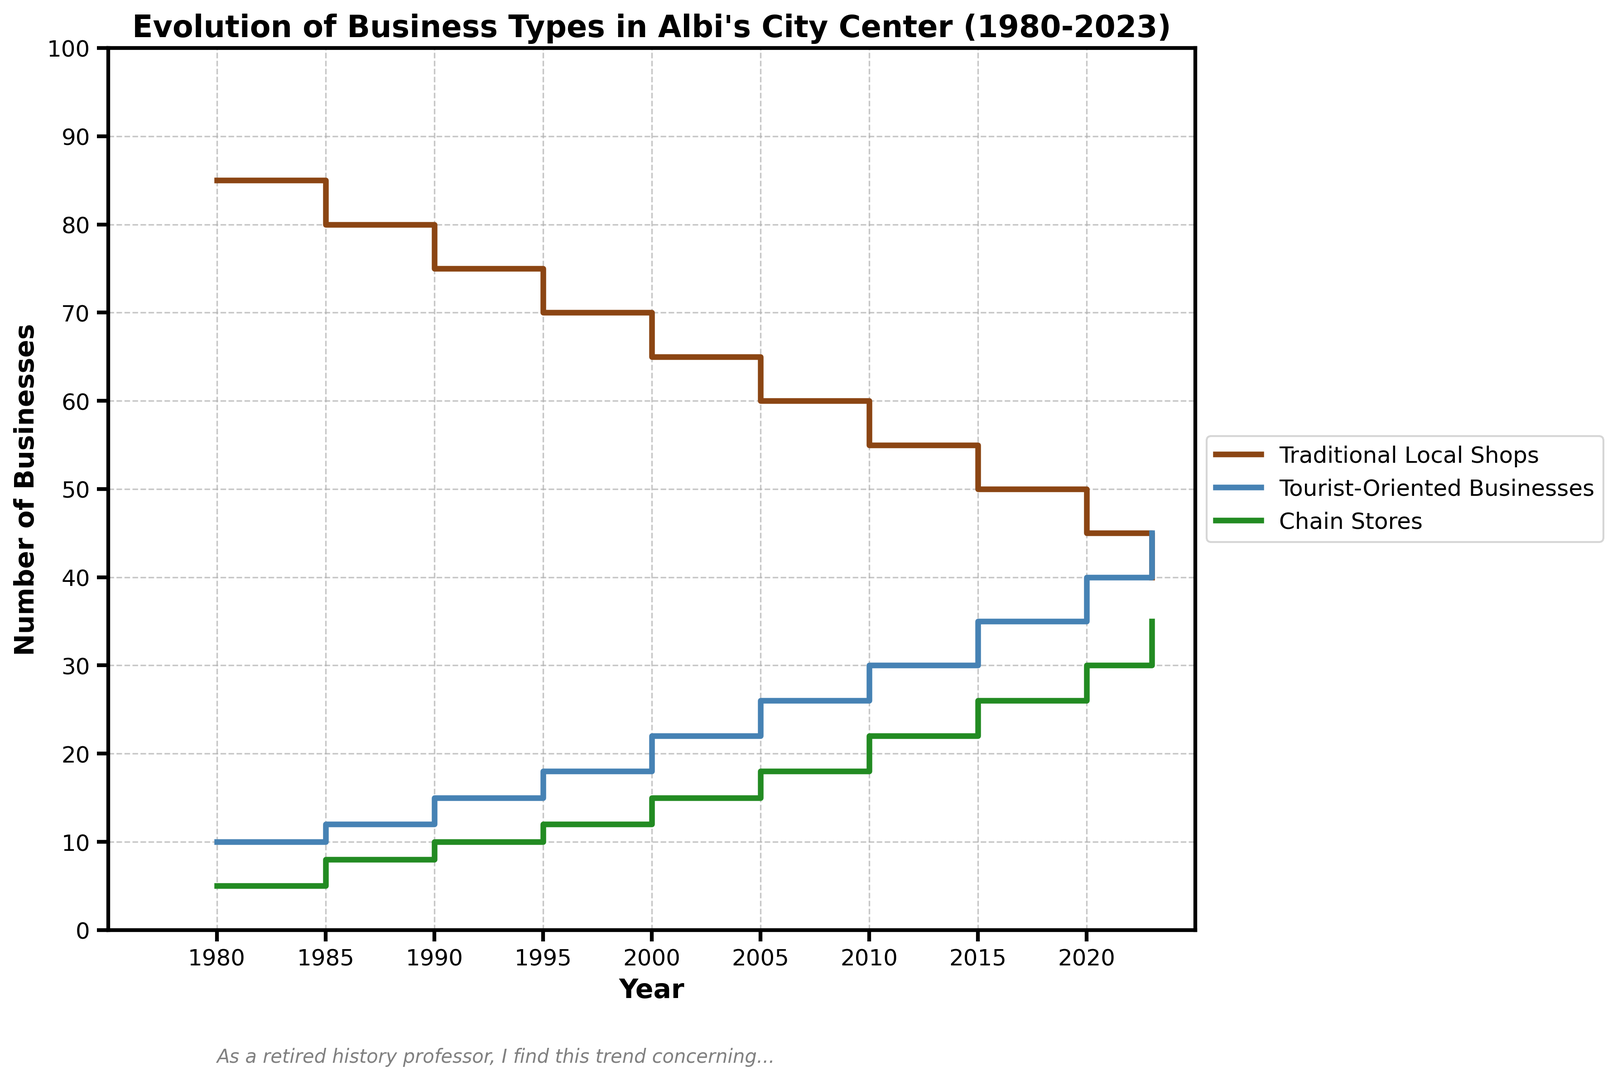What is the overall trend for traditional local shops from 1980 to 2023? Traditional local shops start at 85 in 1980 and steadily decline to 40 by 2023. Thus, the overall trend is a decrease.
Answer: Decrease Has the number of tourist-oriented businesses ever surpassed traditional local shops? If so, when? By comparing the lines representing traditional local shops and tourist-oriented businesses, we see that the latter surpasses the former around the year 2023.
Answer: 2023 How many tourist-oriented businesses were there in 2000 and how much did this number increase by 2023? In 2000, there were 22 tourist-oriented businesses. By 2023, this number increased to 45. The increase is 45 - 22 = 23.
Answer: 23 What year did chain stores first reach a count of 30? Looking at the line for chain stores, it reaches 30 in the year 2020.
Answer: 2020 Which type of business has seen the most significant increase from 1980 to 2023? Tourist-oriented businesses increase from 10 to 45, a change of 35, which is the largest numerical growth compared to traditional local shops and chain stores.
Answer: Tourist-oriented businesses How did the number of traditional local shops and chain stores compare in 1995? In 1995, there were 70 traditional local shops and 12 chain stores. Thus, traditional local shops were far more numerous.
Answer: 70 traditional local shops, 12 chain stores By how much did traditional local shops decrease between 1980 and 2023? Traditional local shops decreased from 85 in 1980 to 40 in 2023. The decrease is 85 - 40 = 45.
Answer: 45 In which year did the number of traditional local shops drop below 50? The year 2015 is when the number of traditional local shops dropped to 50, indicating this is the year they fell below that mark.
Answer: 2015 How does the growth of chain stores compare to the growth of tourist-oriented businesses between 1980 and 2023? Chain stores increase from 5 to 35 (a change of +30), while tourist-oriented businesses increase from 10 to 45 (a change of +35). Thus, tourist-oriented businesses grew more.
Answer: Tourist-oriented businesses grew more What's the total number of all businesses in 2005? In 2005, the numbers are: Traditional Local Shops = 60, Tourist-Oriented Businesses = 26, Chain Stores = 18. Summing these gives 60 + 26 + 18 = 104.
Answer: 104 